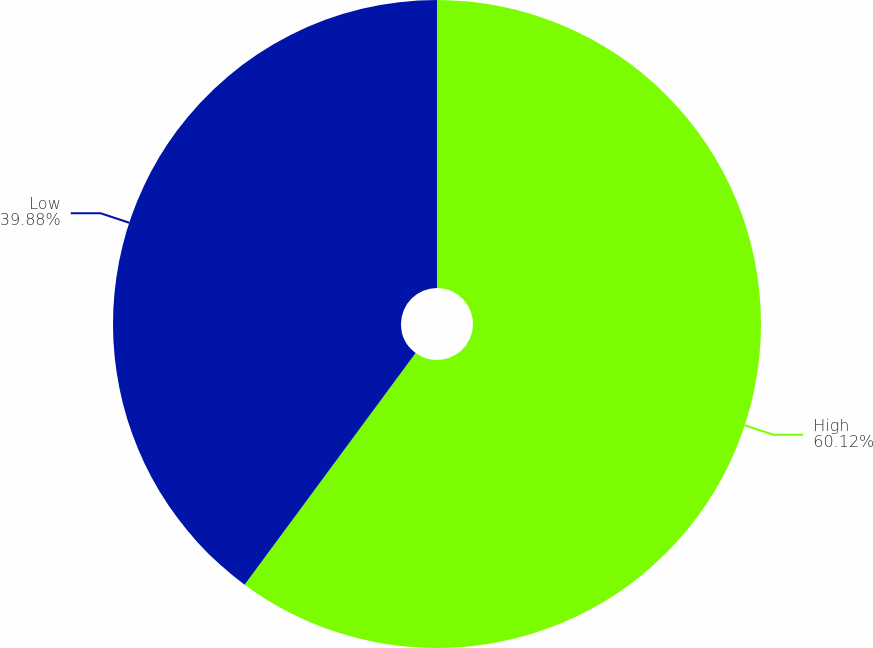<chart> <loc_0><loc_0><loc_500><loc_500><pie_chart><fcel>High<fcel>Low<nl><fcel>60.12%<fcel>39.88%<nl></chart> 